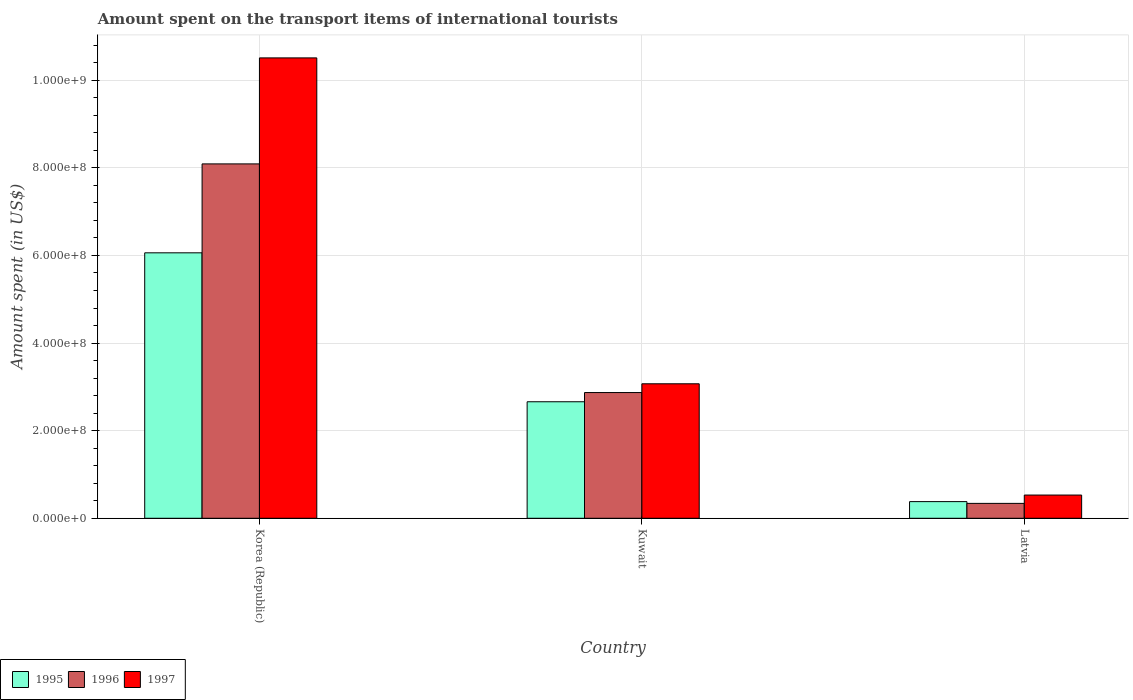Are the number of bars on each tick of the X-axis equal?
Your response must be concise. Yes. What is the label of the 3rd group of bars from the left?
Keep it short and to the point. Latvia. What is the amount spent on the transport items of international tourists in 1996 in Kuwait?
Make the answer very short. 2.87e+08. Across all countries, what is the maximum amount spent on the transport items of international tourists in 1996?
Offer a very short reply. 8.09e+08. Across all countries, what is the minimum amount spent on the transport items of international tourists in 1995?
Your answer should be compact. 3.80e+07. In which country was the amount spent on the transport items of international tourists in 1997 maximum?
Offer a very short reply. Korea (Republic). In which country was the amount spent on the transport items of international tourists in 1996 minimum?
Offer a terse response. Latvia. What is the total amount spent on the transport items of international tourists in 1997 in the graph?
Keep it short and to the point. 1.41e+09. What is the difference between the amount spent on the transport items of international tourists in 1996 in Korea (Republic) and that in Kuwait?
Offer a very short reply. 5.22e+08. What is the difference between the amount spent on the transport items of international tourists in 1996 in Kuwait and the amount spent on the transport items of international tourists in 1997 in Latvia?
Ensure brevity in your answer.  2.34e+08. What is the average amount spent on the transport items of international tourists in 1997 per country?
Give a very brief answer. 4.70e+08. What is the difference between the amount spent on the transport items of international tourists of/in 1995 and amount spent on the transport items of international tourists of/in 1997 in Latvia?
Provide a succinct answer. -1.50e+07. What is the ratio of the amount spent on the transport items of international tourists in 1996 in Korea (Republic) to that in Kuwait?
Offer a terse response. 2.82. Is the difference between the amount spent on the transport items of international tourists in 1995 in Kuwait and Latvia greater than the difference between the amount spent on the transport items of international tourists in 1997 in Kuwait and Latvia?
Your answer should be compact. No. What is the difference between the highest and the second highest amount spent on the transport items of international tourists in 1996?
Give a very brief answer. 7.75e+08. What is the difference between the highest and the lowest amount spent on the transport items of international tourists in 1997?
Give a very brief answer. 9.98e+08. What does the 1st bar from the left in Latvia represents?
Give a very brief answer. 1995. What does the 3rd bar from the right in Korea (Republic) represents?
Your response must be concise. 1995. Are all the bars in the graph horizontal?
Your answer should be compact. No. Are the values on the major ticks of Y-axis written in scientific E-notation?
Your answer should be very brief. Yes. Does the graph contain grids?
Provide a short and direct response. Yes. Where does the legend appear in the graph?
Your answer should be very brief. Bottom left. How are the legend labels stacked?
Keep it short and to the point. Horizontal. What is the title of the graph?
Give a very brief answer. Amount spent on the transport items of international tourists. Does "1998" appear as one of the legend labels in the graph?
Your answer should be compact. No. What is the label or title of the X-axis?
Give a very brief answer. Country. What is the label or title of the Y-axis?
Your answer should be very brief. Amount spent (in US$). What is the Amount spent (in US$) in 1995 in Korea (Republic)?
Make the answer very short. 6.06e+08. What is the Amount spent (in US$) of 1996 in Korea (Republic)?
Your answer should be compact. 8.09e+08. What is the Amount spent (in US$) in 1997 in Korea (Republic)?
Offer a terse response. 1.05e+09. What is the Amount spent (in US$) of 1995 in Kuwait?
Your response must be concise. 2.66e+08. What is the Amount spent (in US$) in 1996 in Kuwait?
Give a very brief answer. 2.87e+08. What is the Amount spent (in US$) in 1997 in Kuwait?
Offer a very short reply. 3.07e+08. What is the Amount spent (in US$) of 1995 in Latvia?
Ensure brevity in your answer.  3.80e+07. What is the Amount spent (in US$) of 1996 in Latvia?
Provide a short and direct response. 3.40e+07. What is the Amount spent (in US$) of 1997 in Latvia?
Provide a succinct answer. 5.30e+07. Across all countries, what is the maximum Amount spent (in US$) of 1995?
Your answer should be compact. 6.06e+08. Across all countries, what is the maximum Amount spent (in US$) of 1996?
Your answer should be very brief. 8.09e+08. Across all countries, what is the maximum Amount spent (in US$) of 1997?
Offer a very short reply. 1.05e+09. Across all countries, what is the minimum Amount spent (in US$) in 1995?
Provide a short and direct response. 3.80e+07. Across all countries, what is the minimum Amount spent (in US$) in 1996?
Make the answer very short. 3.40e+07. Across all countries, what is the minimum Amount spent (in US$) in 1997?
Provide a short and direct response. 5.30e+07. What is the total Amount spent (in US$) in 1995 in the graph?
Offer a very short reply. 9.10e+08. What is the total Amount spent (in US$) in 1996 in the graph?
Give a very brief answer. 1.13e+09. What is the total Amount spent (in US$) of 1997 in the graph?
Your answer should be compact. 1.41e+09. What is the difference between the Amount spent (in US$) in 1995 in Korea (Republic) and that in Kuwait?
Your response must be concise. 3.40e+08. What is the difference between the Amount spent (in US$) in 1996 in Korea (Republic) and that in Kuwait?
Keep it short and to the point. 5.22e+08. What is the difference between the Amount spent (in US$) of 1997 in Korea (Republic) and that in Kuwait?
Offer a terse response. 7.44e+08. What is the difference between the Amount spent (in US$) of 1995 in Korea (Republic) and that in Latvia?
Your answer should be compact. 5.68e+08. What is the difference between the Amount spent (in US$) of 1996 in Korea (Republic) and that in Latvia?
Offer a terse response. 7.75e+08. What is the difference between the Amount spent (in US$) of 1997 in Korea (Republic) and that in Latvia?
Your answer should be very brief. 9.98e+08. What is the difference between the Amount spent (in US$) in 1995 in Kuwait and that in Latvia?
Keep it short and to the point. 2.28e+08. What is the difference between the Amount spent (in US$) of 1996 in Kuwait and that in Latvia?
Ensure brevity in your answer.  2.53e+08. What is the difference between the Amount spent (in US$) of 1997 in Kuwait and that in Latvia?
Ensure brevity in your answer.  2.54e+08. What is the difference between the Amount spent (in US$) of 1995 in Korea (Republic) and the Amount spent (in US$) of 1996 in Kuwait?
Make the answer very short. 3.19e+08. What is the difference between the Amount spent (in US$) in 1995 in Korea (Republic) and the Amount spent (in US$) in 1997 in Kuwait?
Your answer should be very brief. 2.99e+08. What is the difference between the Amount spent (in US$) of 1996 in Korea (Republic) and the Amount spent (in US$) of 1997 in Kuwait?
Your answer should be very brief. 5.02e+08. What is the difference between the Amount spent (in US$) in 1995 in Korea (Republic) and the Amount spent (in US$) in 1996 in Latvia?
Keep it short and to the point. 5.72e+08. What is the difference between the Amount spent (in US$) of 1995 in Korea (Republic) and the Amount spent (in US$) of 1997 in Latvia?
Offer a very short reply. 5.53e+08. What is the difference between the Amount spent (in US$) of 1996 in Korea (Republic) and the Amount spent (in US$) of 1997 in Latvia?
Keep it short and to the point. 7.56e+08. What is the difference between the Amount spent (in US$) of 1995 in Kuwait and the Amount spent (in US$) of 1996 in Latvia?
Your answer should be compact. 2.32e+08. What is the difference between the Amount spent (in US$) of 1995 in Kuwait and the Amount spent (in US$) of 1997 in Latvia?
Your answer should be compact. 2.13e+08. What is the difference between the Amount spent (in US$) in 1996 in Kuwait and the Amount spent (in US$) in 1997 in Latvia?
Your answer should be compact. 2.34e+08. What is the average Amount spent (in US$) of 1995 per country?
Ensure brevity in your answer.  3.03e+08. What is the average Amount spent (in US$) of 1996 per country?
Provide a succinct answer. 3.77e+08. What is the average Amount spent (in US$) in 1997 per country?
Provide a succinct answer. 4.70e+08. What is the difference between the Amount spent (in US$) in 1995 and Amount spent (in US$) in 1996 in Korea (Republic)?
Your answer should be compact. -2.03e+08. What is the difference between the Amount spent (in US$) in 1995 and Amount spent (in US$) in 1997 in Korea (Republic)?
Ensure brevity in your answer.  -4.45e+08. What is the difference between the Amount spent (in US$) in 1996 and Amount spent (in US$) in 1997 in Korea (Republic)?
Provide a succinct answer. -2.42e+08. What is the difference between the Amount spent (in US$) in 1995 and Amount spent (in US$) in 1996 in Kuwait?
Your response must be concise. -2.10e+07. What is the difference between the Amount spent (in US$) in 1995 and Amount spent (in US$) in 1997 in Kuwait?
Make the answer very short. -4.10e+07. What is the difference between the Amount spent (in US$) of 1996 and Amount spent (in US$) of 1997 in Kuwait?
Your answer should be compact. -2.00e+07. What is the difference between the Amount spent (in US$) in 1995 and Amount spent (in US$) in 1996 in Latvia?
Offer a very short reply. 4.00e+06. What is the difference between the Amount spent (in US$) of 1995 and Amount spent (in US$) of 1997 in Latvia?
Offer a very short reply. -1.50e+07. What is the difference between the Amount spent (in US$) in 1996 and Amount spent (in US$) in 1997 in Latvia?
Give a very brief answer. -1.90e+07. What is the ratio of the Amount spent (in US$) in 1995 in Korea (Republic) to that in Kuwait?
Keep it short and to the point. 2.28. What is the ratio of the Amount spent (in US$) of 1996 in Korea (Republic) to that in Kuwait?
Make the answer very short. 2.82. What is the ratio of the Amount spent (in US$) in 1997 in Korea (Republic) to that in Kuwait?
Your answer should be very brief. 3.42. What is the ratio of the Amount spent (in US$) of 1995 in Korea (Republic) to that in Latvia?
Give a very brief answer. 15.95. What is the ratio of the Amount spent (in US$) of 1996 in Korea (Republic) to that in Latvia?
Keep it short and to the point. 23.79. What is the ratio of the Amount spent (in US$) in 1997 in Korea (Republic) to that in Latvia?
Provide a succinct answer. 19.83. What is the ratio of the Amount spent (in US$) of 1995 in Kuwait to that in Latvia?
Your answer should be very brief. 7. What is the ratio of the Amount spent (in US$) in 1996 in Kuwait to that in Latvia?
Offer a terse response. 8.44. What is the ratio of the Amount spent (in US$) in 1997 in Kuwait to that in Latvia?
Your answer should be compact. 5.79. What is the difference between the highest and the second highest Amount spent (in US$) in 1995?
Your answer should be very brief. 3.40e+08. What is the difference between the highest and the second highest Amount spent (in US$) of 1996?
Offer a terse response. 5.22e+08. What is the difference between the highest and the second highest Amount spent (in US$) in 1997?
Your answer should be very brief. 7.44e+08. What is the difference between the highest and the lowest Amount spent (in US$) of 1995?
Make the answer very short. 5.68e+08. What is the difference between the highest and the lowest Amount spent (in US$) of 1996?
Provide a short and direct response. 7.75e+08. What is the difference between the highest and the lowest Amount spent (in US$) of 1997?
Offer a terse response. 9.98e+08. 